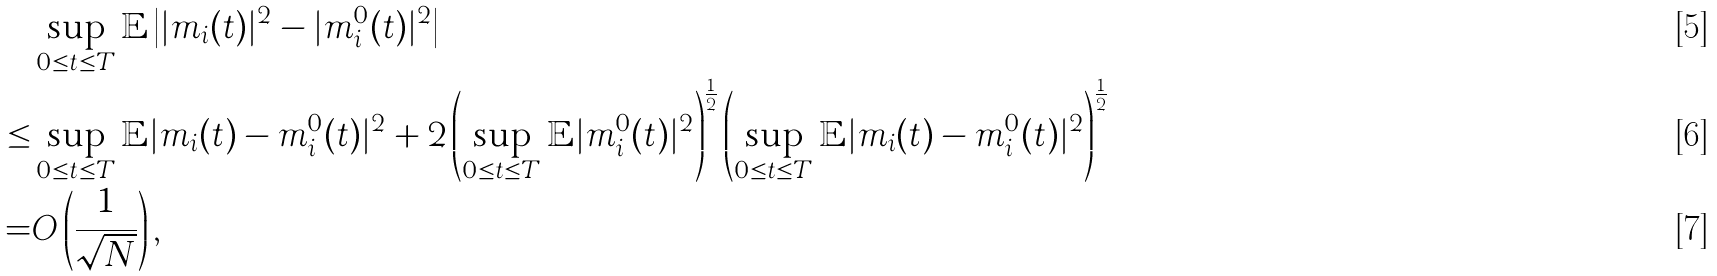<formula> <loc_0><loc_0><loc_500><loc_500>& \sup _ { 0 \leq t \leq T } \mathbb { E } \left | | m _ { i } ( t ) | ^ { 2 } - | m ^ { 0 } _ { i } ( t ) | ^ { 2 } \right | \\ \leq & \sup _ { 0 \leq t \leq T } \mathbb { E } | m _ { i } ( t ) - m ^ { 0 } _ { i } ( t ) | ^ { 2 } + 2 \left ( \sup _ { 0 \leq t \leq T } \mathbb { E } | m ^ { 0 } _ { i } ( t ) | ^ { 2 } \right ) ^ { \frac { 1 } { 2 } } \left ( \sup _ { 0 \leq t \leq T } \mathbb { E } | m _ { i } ( t ) - m ^ { 0 } _ { i } ( t ) | ^ { 2 } \right ) ^ { \frac { 1 } { 2 } } \\ = & O \left ( \frac { 1 } { \sqrt { N } } \right ) ,</formula> 